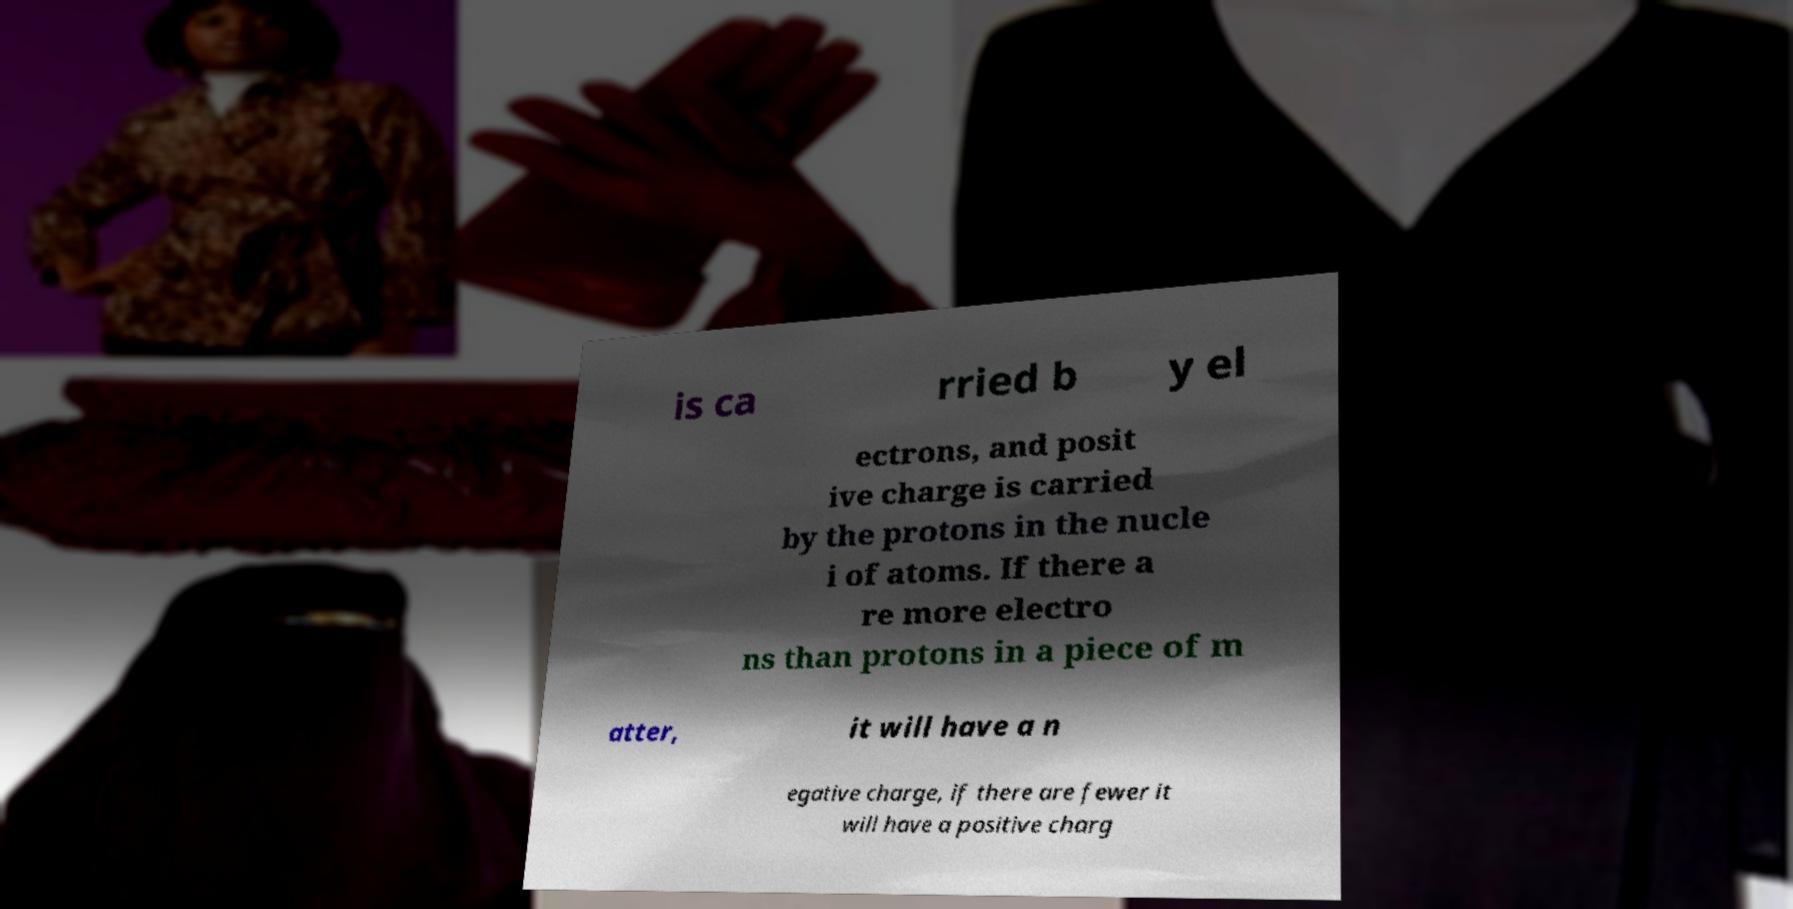I need the written content from this picture converted into text. Can you do that? is ca rried b y el ectrons, and posit ive charge is carried by the protons in the nucle i of atoms. If there a re more electro ns than protons in a piece of m atter, it will have a n egative charge, if there are fewer it will have a positive charg 